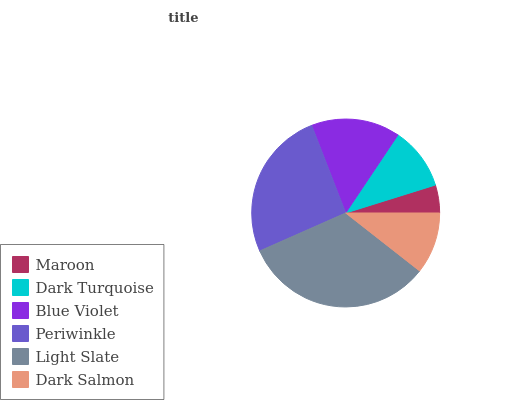Is Maroon the minimum?
Answer yes or no. Yes. Is Light Slate the maximum?
Answer yes or no. Yes. Is Dark Turquoise the minimum?
Answer yes or no. No. Is Dark Turquoise the maximum?
Answer yes or no. No. Is Dark Turquoise greater than Maroon?
Answer yes or no. Yes. Is Maroon less than Dark Turquoise?
Answer yes or no. Yes. Is Maroon greater than Dark Turquoise?
Answer yes or no. No. Is Dark Turquoise less than Maroon?
Answer yes or no. No. Is Blue Violet the high median?
Answer yes or no. Yes. Is Dark Turquoise the low median?
Answer yes or no. Yes. Is Periwinkle the high median?
Answer yes or no. No. Is Maroon the low median?
Answer yes or no. No. 